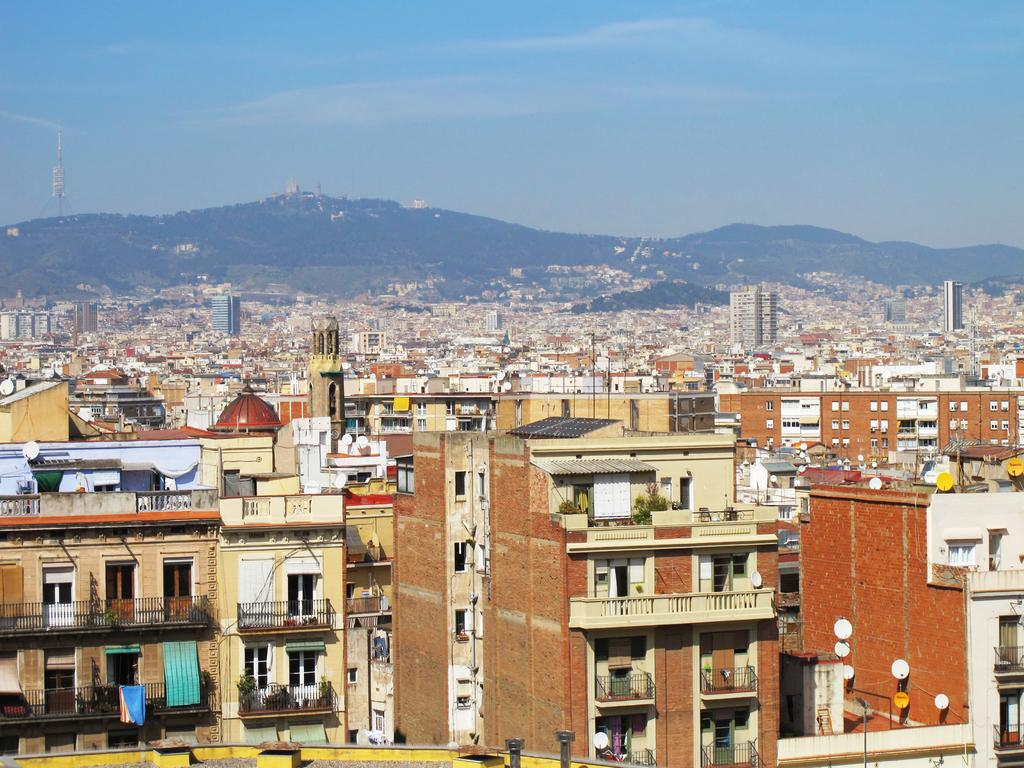What can be seen in the background of the image? There is a clear blue sky and hills visible in the background of the image. What type of structures are present in the image? There are buildings in the image. Are there any architectural features on the buildings? Yes, there are balconies on the buildings. What type of vegetation is present in the image? House plants are present in the image. What type of advertisement can be seen on the side of the building in the image? There is no advertisement present on the side of the building in the image. What is the father doing in the image? There is no person, let alone a father, present in the image. 